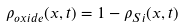<formula> <loc_0><loc_0><loc_500><loc_500>\rho _ { o x i d e } ( x , t ) = 1 - \rho _ { S i } ( x , t )</formula> 